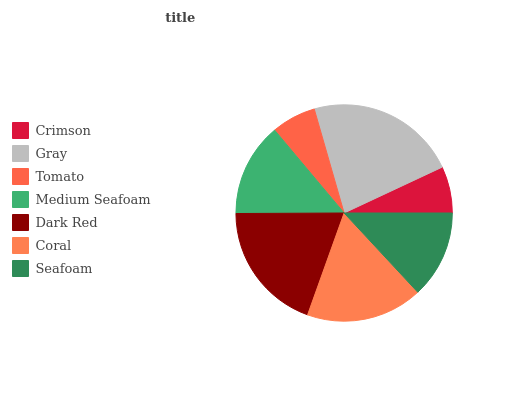Is Tomato the minimum?
Answer yes or no. Yes. Is Gray the maximum?
Answer yes or no. Yes. Is Gray the minimum?
Answer yes or no. No. Is Tomato the maximum?
Answer yes or no. No. Is Gray greater than Tomato?
Answer yes or no. Yes. Is Tomato less than Gray?
Answer yes or no. Yes. Is Tomato greater than Gray?
Answer yes or no. No. Is Gray less than Tomato?
Answer yes or no. No. Is Medium Seafoam the high median?
Answer yes or no. Yes. Is Medium Seafoam the low median?
Answer yes or no. Yes. Is Tomato the high median?
Answer yes or no. No. Is Seafoam the low median?
Answer yes or no. No. 